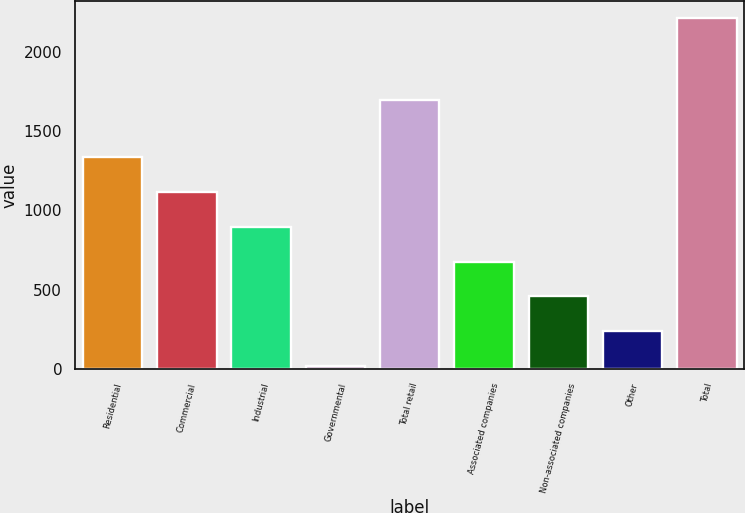<chart> <loc_0><loc_0><loc_500><loc_500><bar_chart><fcel>Residential<fcel>Commercial<fcel>Industrial<fcel>Governmental<fcel>Total retail<fcel>Associated companies<fcel>Non-associated companies<fcel>Other<fcel>Total<nl><fcel>1335<fcel>1116<fcel>897<fcel>21<fcel>1698<fcel>678<fcel>459<fcel>240<fcel>2211<nl></chart> 